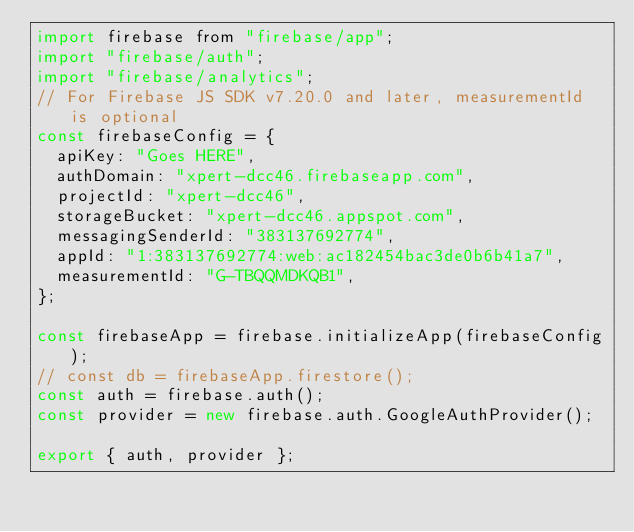Convert code to text. <code><loc_0><loc_0><loc_500><loc_500><_JavaScript_>import firebase from "firebase/app";
import "firebase/auth";
import "firebase/analytics";
// For Firebase JS SDK v7.20.0 and later, measurementId is optional
const firebaseConfig = {
  apiKey: "Goes HERE",
  authDomain: "xpert-dcc46.firebaseapp.com",
  projectId: "xpert-dcc46",
  storageBucket: "xpert-dcc46.appspot.com",
  messagingSenderId: "383137692774",
  appId: "1:383137692774:web:ac182454bac3de0b6b41a7",
  measurementId: "G-TBQQMDKQB1",
};

const firebaseApp = firebase.initializeApp(firebaseConfig);
// const db = firebaseApp.firestore();
const auth = firebase.auth();
const provider = new firebase.auth.GoogleAuthProvider();

export { auth, provider };
</code> 